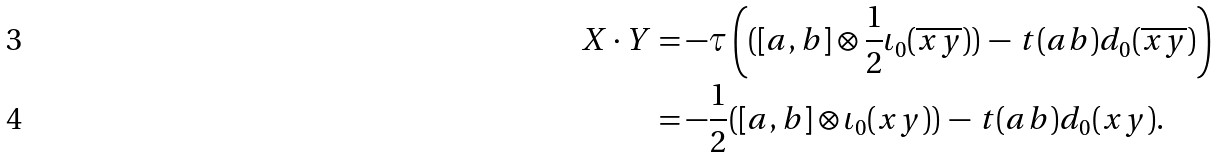Convert formula to latex. <formula><loc_0><loc_0><loc_500><loc_500>X \cdot Y & = - \tau \left ( ( [ a , b ] \otimes \frac { 1 } { 2 } \iota _ { 0 } ( \overline { x y } ) ) \, - \, t ( a b ) d _ { 0 } ( \overline { x y } ) \right ) \\ & = - \frac { 1 } { 2 } ( [ a , b ] \otimes \iota _ { 0 } ( x y ) ) \, - \, t ( a b ) d _ { 0 } ( x y ) .</formula> 